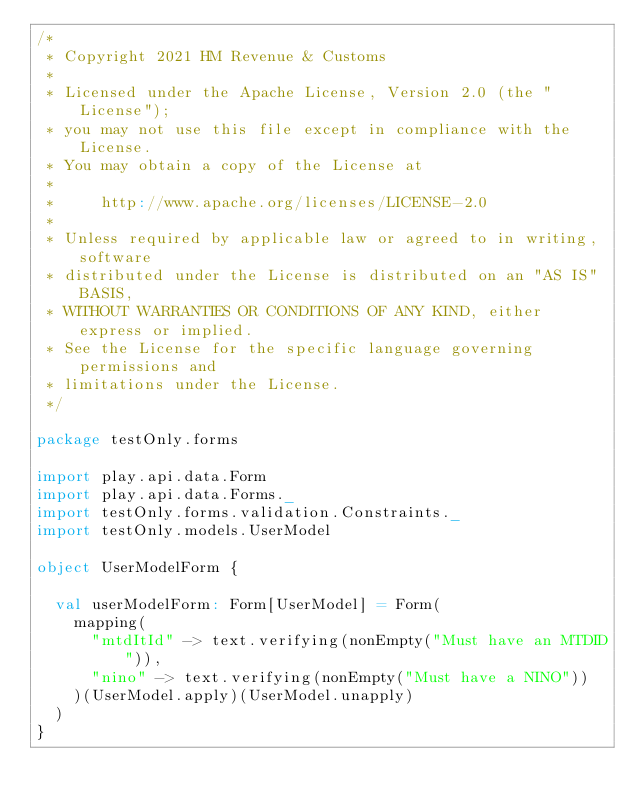Convert code to text. <code><loc_0><loc_0><loc_500><loc_500><_Scala_>/*
 * Copyright 2021 HM Revenue & Customs
 *
 * Licensed under the Apache License, Version 2.0 (the "License");
 * you may not use this file except in compliance with the License.
 * You may obtain a copy of the License at
 *
 *     http://www.apache.org/licenses/LICENSE-2.0
 *
 * Unless required by applicable law or agreed to in writing, software
 * distributed under the License is distributed on an "AS IS" BASIS,
 * WITHOUT WARRANTIES OR CONDITIONS OF ANY KIND, either express or implied.
 * See the License for the specific language governing permissions and
 * limitations under the License.
 */

package testOnly.forms

import play.api.data.Form
import play.api.data.Forms._
import testOnly.forms.validation.Constraints._
import testOnly.models.UserModel

object UserModelForm {

  val userModelForm: Form[UserModel] = Form(
    mapping(
      "mtdItId" -> text.verifying(nonEmpty("Must have an MTDID")),
      "nino" -> text.verifying(nonEmpty("Must have a NINO"))
    )(UserModel.apply)(UserModel.unapply)
  )
}
</code> 